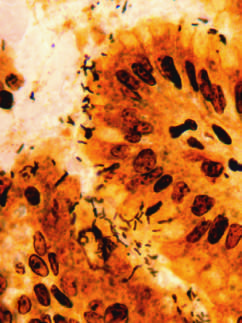re iron deposits shown by a special staining process abundant within surface mucus?
Answer the question using a single word or phrase. No 